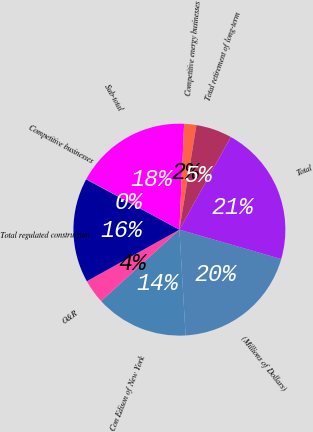Convert chart to OTSL. <chart><loc_0><loc_0><loc_500><loc_500><pie_chart><fcel>(Millions of Dollars)<fcel>Con Edison of New York<fcel>O&R<fcel>Total regulated construction<fcel>Competitive businesses<fcel>Sub-total<fcel>Competitive energy businesses<fcel>Total retirement of long-term<fcel>Total<nl><fcel>19.6%<fcel>14.16%<fcel>3.68%<fcel>15.97%<fcel>0.05%<fcel>17.78%<fcel>1.86%<fcel>5.49%<fcel>21.41%<nl></chart> 